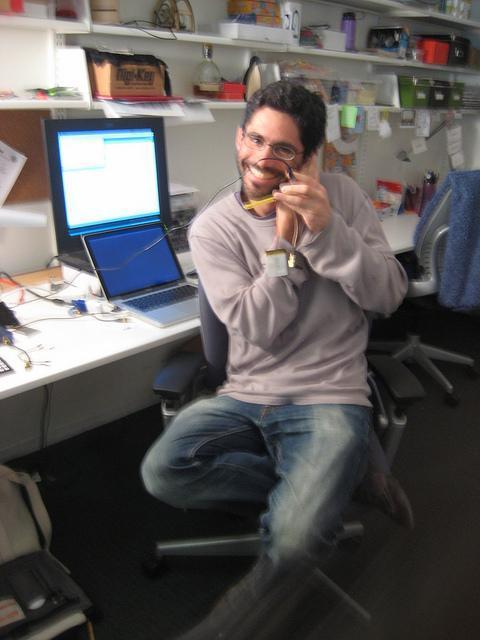How many computers can you see?
Give a very brief answer. 2. How many chairs are there?
Give a very brief answer. 2. How many laptops can be seen?
Give a very brief answer. 2. How many airplanes are in front of the control towers?
Give a very brief answer. 0. 